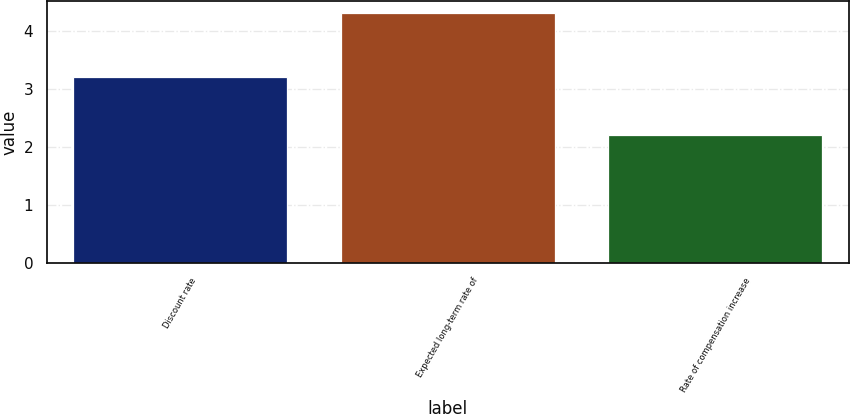Convert chart to OTSL. <chart><loc_0><loc_0><loc_500><loc_500><bar_chart><fcel>Discount rate<fcel>Expected long-term rate of<fcel>Rate of compensation increase<nl><fcel>3.2<fcel>4.3<fcel>2.2<nl></chart> 